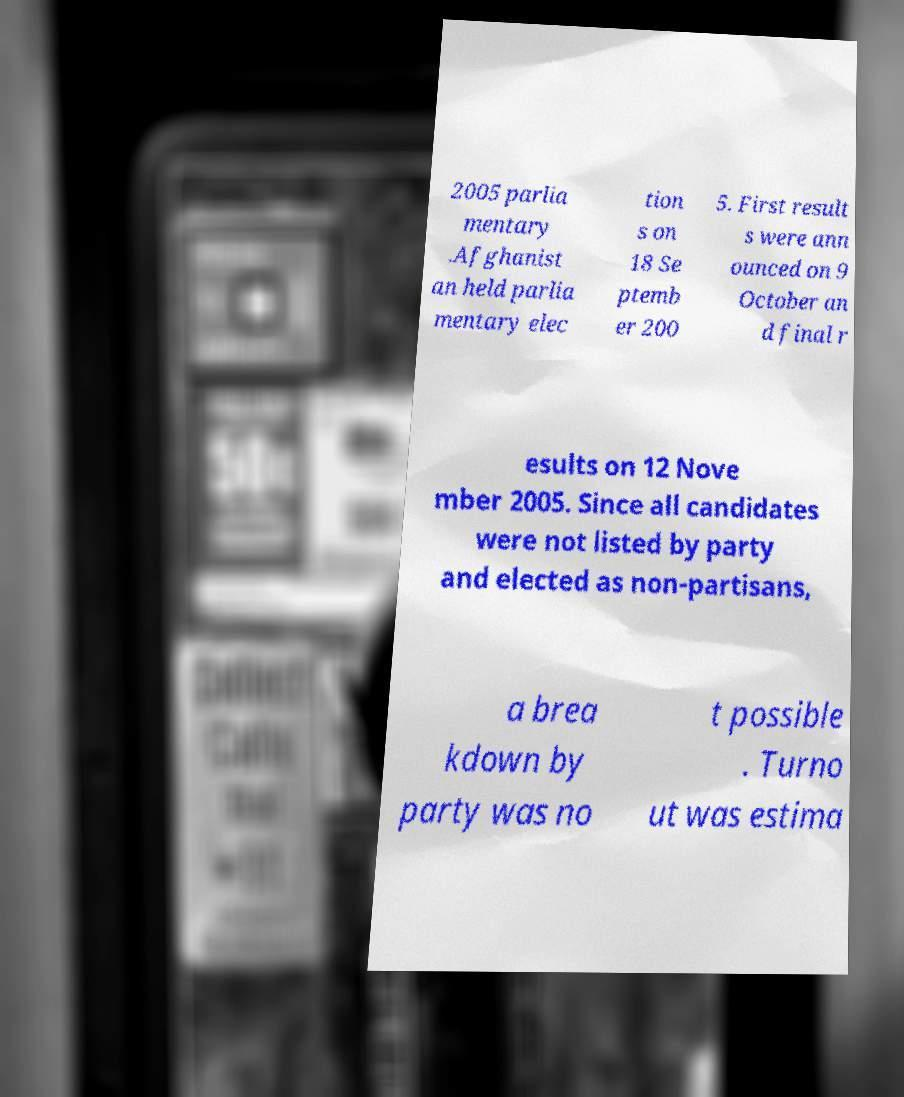What messages or text are displayed in this image? I need them in a readable, typed format. 2005 parlia mentary .Afghanist an held parlia mentary elec tion s on 18 Se ptemb er 200 5. First result s were ann ounced on 9 October an d final r esults on 12 Nove mber 2005. Since all candidates were not listed by party and elected as non-partisans, a brea kdown by party was no t possible . Turno ut was estima 